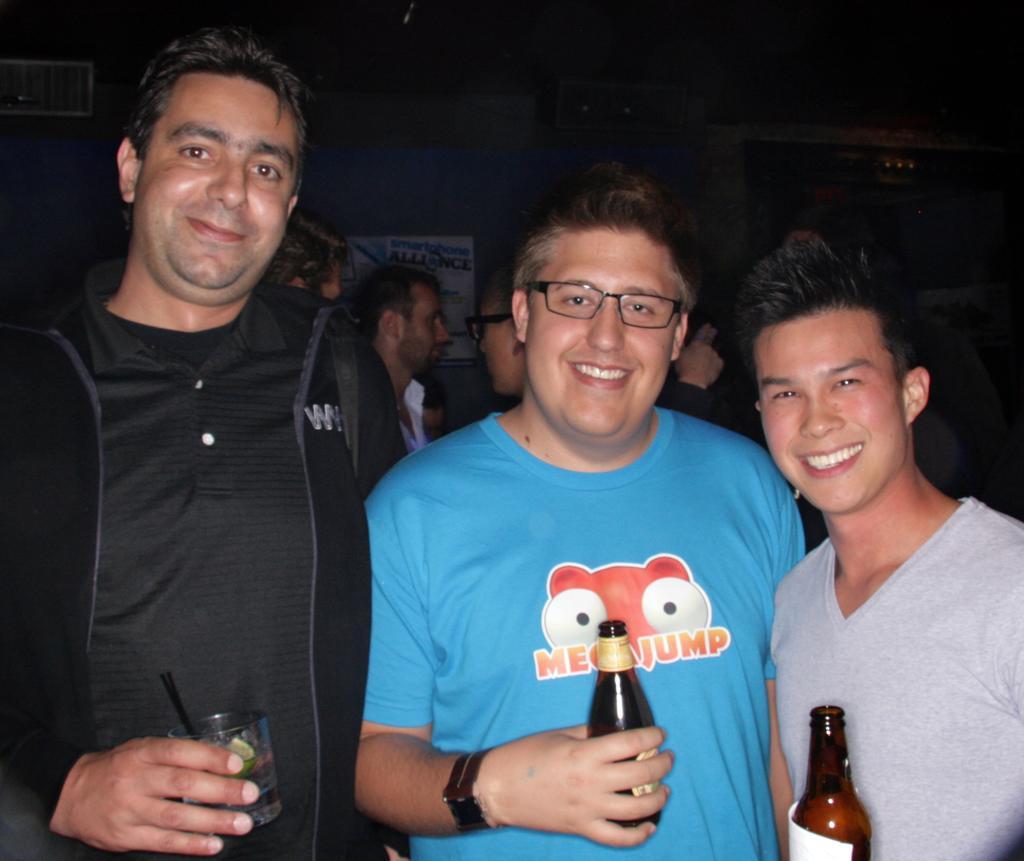How would you summarize this image in a sentence or two? This picture shows three men standing and we see bottles in their hands and a man holding a glass in his hand 